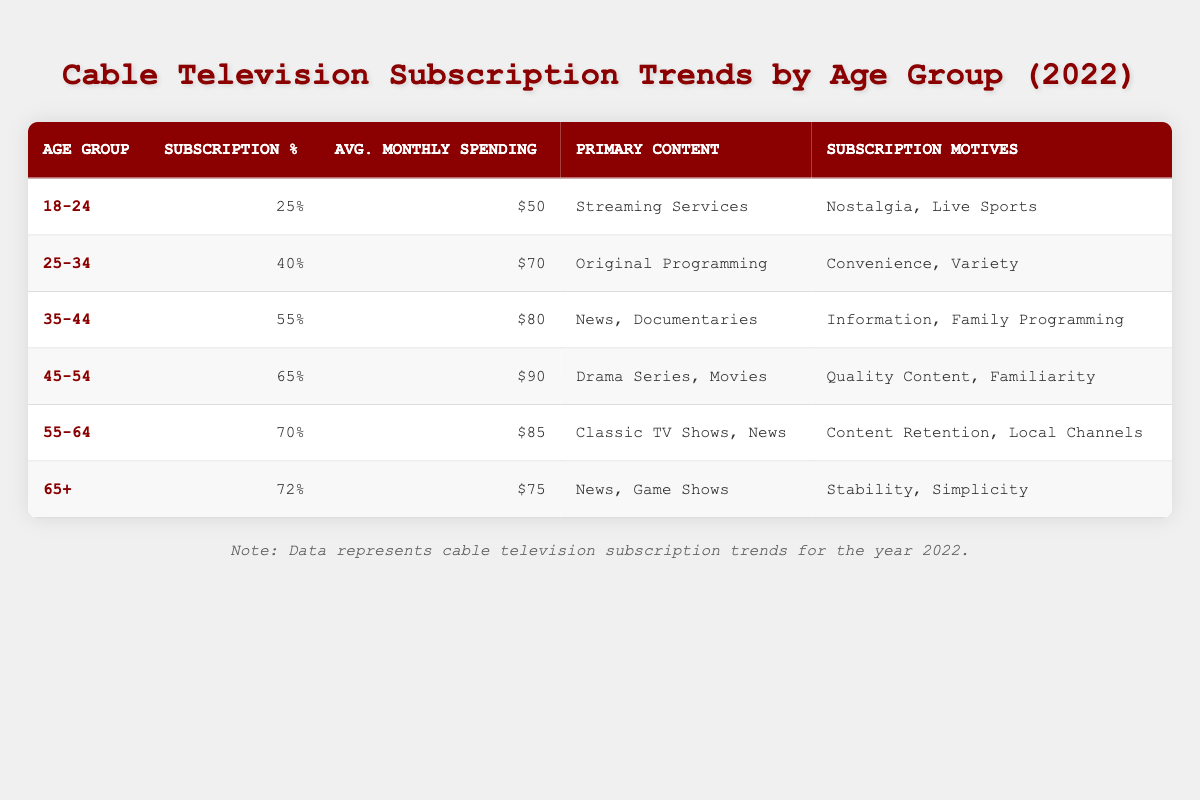What is the subscription percentage for the age group 35-44? The table indicates that the subscription percentage for the age group 35-44 is listed directly under the "Subscription %" column for this age group, which is 55%.
Answer: 55% What is the average monthly spending for the age group 45-54? The average monthly spending for the age group 45-54 can be found in the corresponding row under the "Avg. Monthly Spending" column, which states $90.
Answer: $90 Which age group has the highest subscription percentage? By scanning the "Subscription %" column, we can see that the age group 65+ has the highest subscription percentage at 72%.
Answer: 65+ Is it true that individuals aged 25-34 have the lowest average monthly spending? By comparing the "Avg. Monthly Spending" values of the 25-34 age group ($70) with those of other age groups, particularly the 18-24 age group ($50), it is clear that 25-34 does not have the lowest average spending. The age group 18-24 has the lowest. Thus, this statement is false.
Answer: No What is the difference in average monthly spending between the age groups 55-64 and 45-54? To find the difference, subtract the average monthly spending of the 45-54 age group ($90) from that of the 55-64 age group ($85). The calculation would be $85 - $90 = -$5, indicating that the 55-64 age group spends $5 less than the 45-54 group.
Answer: -5 What is the primary content consumption for the age group 18-24? The primary content consumption for the age group 18-24 is listed in the corresponding row under the "Primary Content" column, which states "Streaming Services."
Answer: Streaming Services What are the motives for subscription for individuals aged 65 and older? The motives for subscription for the 65+ age group are presented in the "Subscription Motives" column, which states "Stability, Simplicity."
Answer: Stability, Simplicity How many age groups have a subscription percentage of 70% or higher? By reviewing the "Subscription %" column, we see that there are three age groups (55-64, 65+) with subscription percentages of 70% or higher. We can count these to find the total.
Answer: 2 Which age group spends the most on average monthly cable subscriptions? Looking at the "Avg. Monthly Spending" column, the age group 45-54 spends the most on average, which is $90.
Answer: $90 